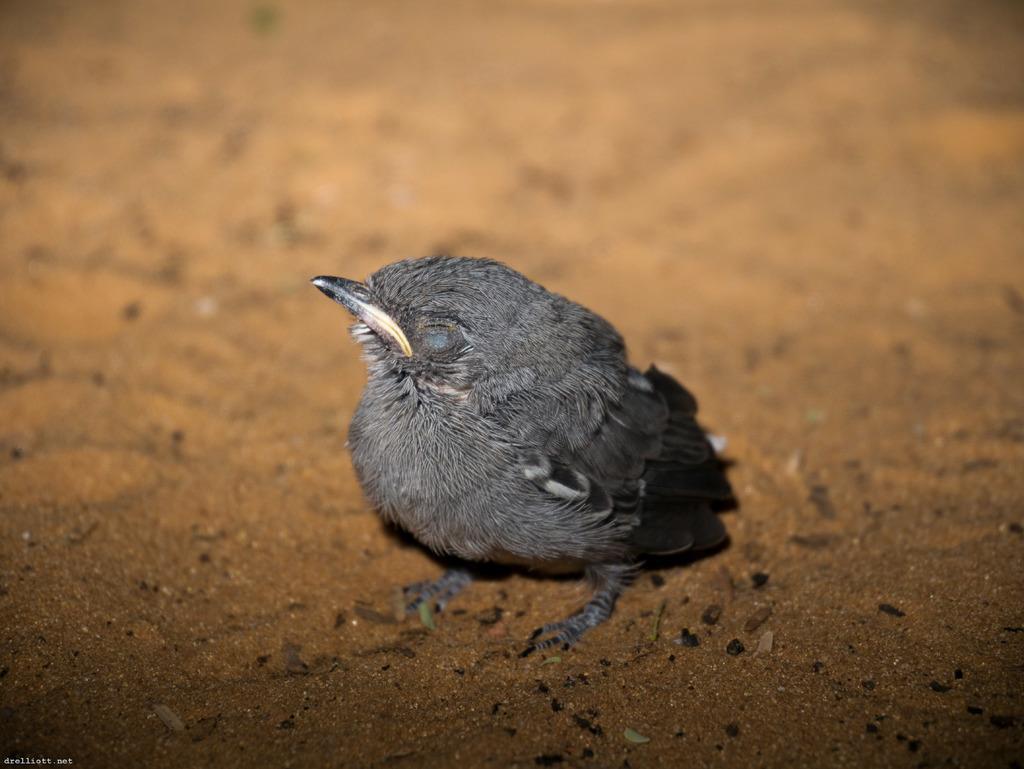Could you give a brief overview of what you see in this image? In this picture there is a small bird in the center of the image. 